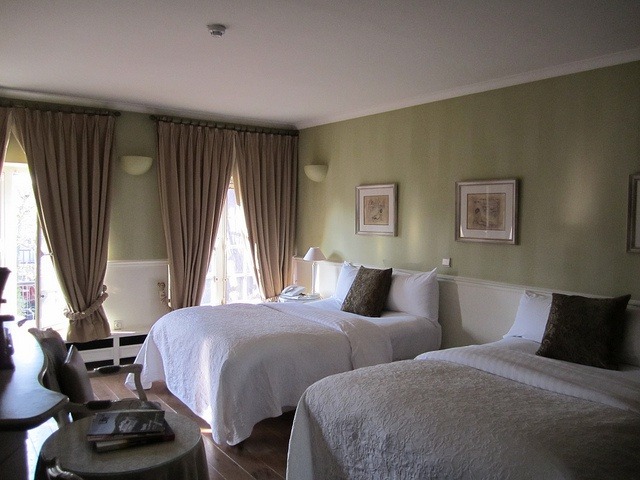Describe the objects in this image and their specific colors. I can see bed in gray and black tones, bed in gray, darkgray, and lavender tones, chair in gray and black tones, book in gray and black tones, and book in gray and black tones in this image. 